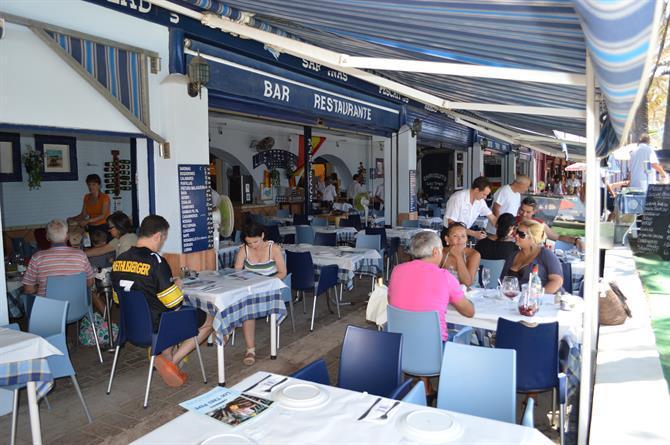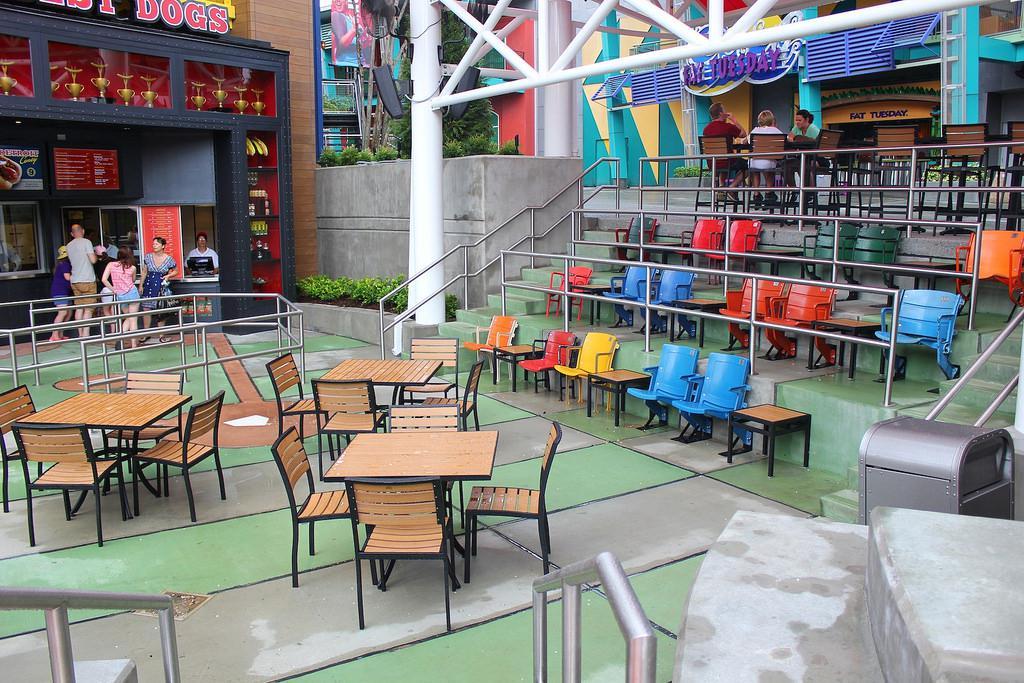The first image is the image on the left, the second image is the image on the right. Analyze the images presented: Is the assertion "There is an employee of the business in one of the images." valid? Answer yes or no. Yes. 